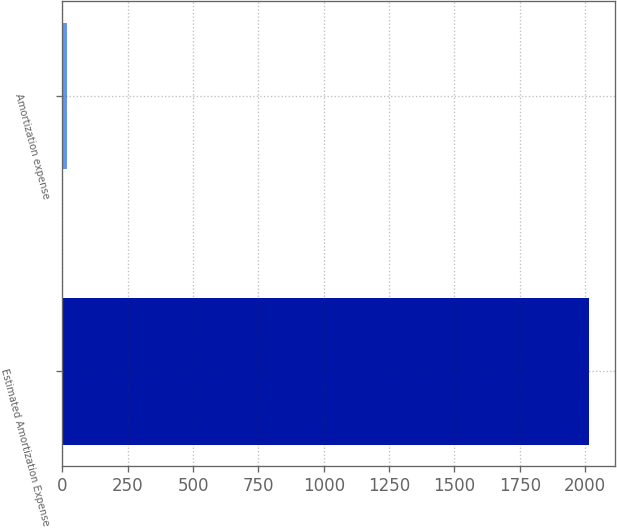Convert chart. <chart><loc_0><loc_0><loc_500><loc_500><bar_chart><fcel>Estimated Amortization Expense<fcel>Amortization expense<nl><fcel>2015<fcel>16<nl></chart> 